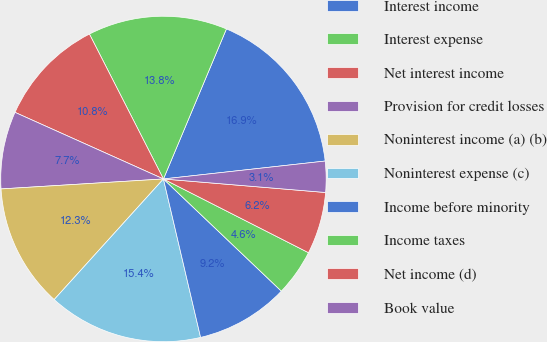Convert chart to OTSL. <chart><loc_0><loc_0><loc_500><loc_500><pie_chart><fcel>Interest income<fcel>Interest expense<fcel>Net interest income<fcel>Provision for credit losses<fcel>Noninterest income (a) (b)<fcel>Noninterest expense (c)<fcel>Income before minority<fcel>Income taxes<fcel>Net income (d)<fcel>Book value<nl><fcel>16.92%<fcel>13.84%<fcel>10.77%<fcel>7.69%<fcel>12.31%<fcel>15.38%<fcel>9.23%<fcel>4.62%<fcel>6.16%<fcel>3.08%<nl></chart> 